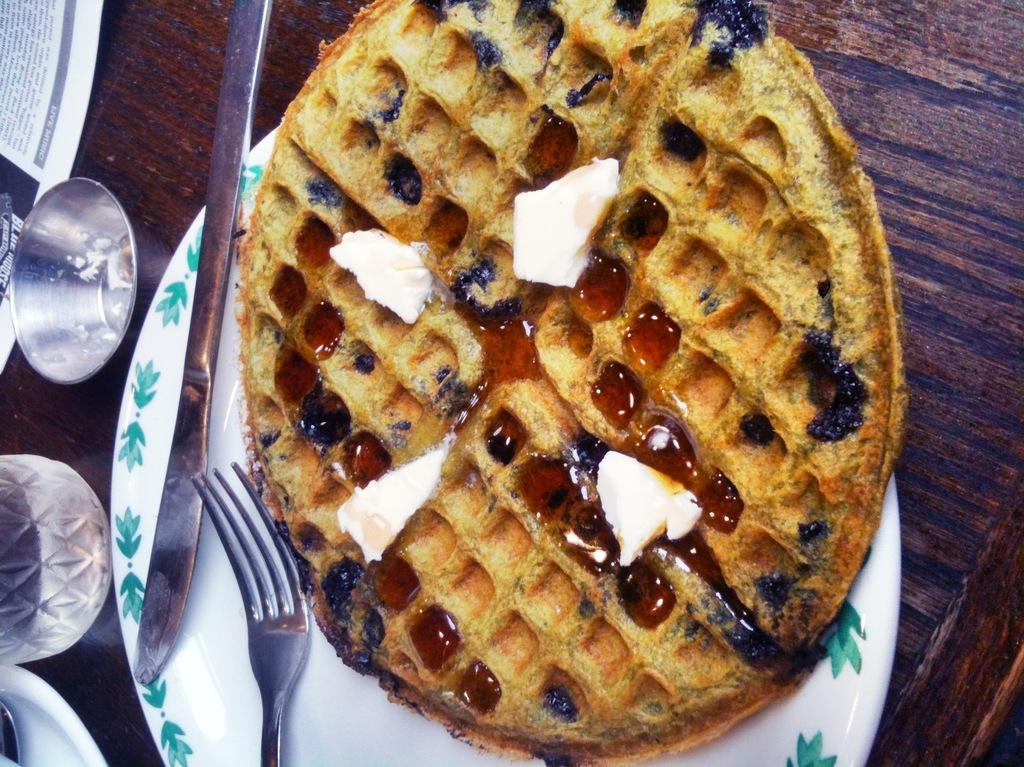What is the main object in the center of the image? There is a plate in the center of the image. What is on the plate? The plate has a waffle on it. What utensils are on the plate? There is a fork and a knife on the plate. What other objects are on the left side of the image? There is a glass and a bowl on the left side of the image. What time of day is it in the image, considering the afternoon? The time of day is not mentioned or indicated in the image, so it cannot be determined whether it is afternoon or not. 